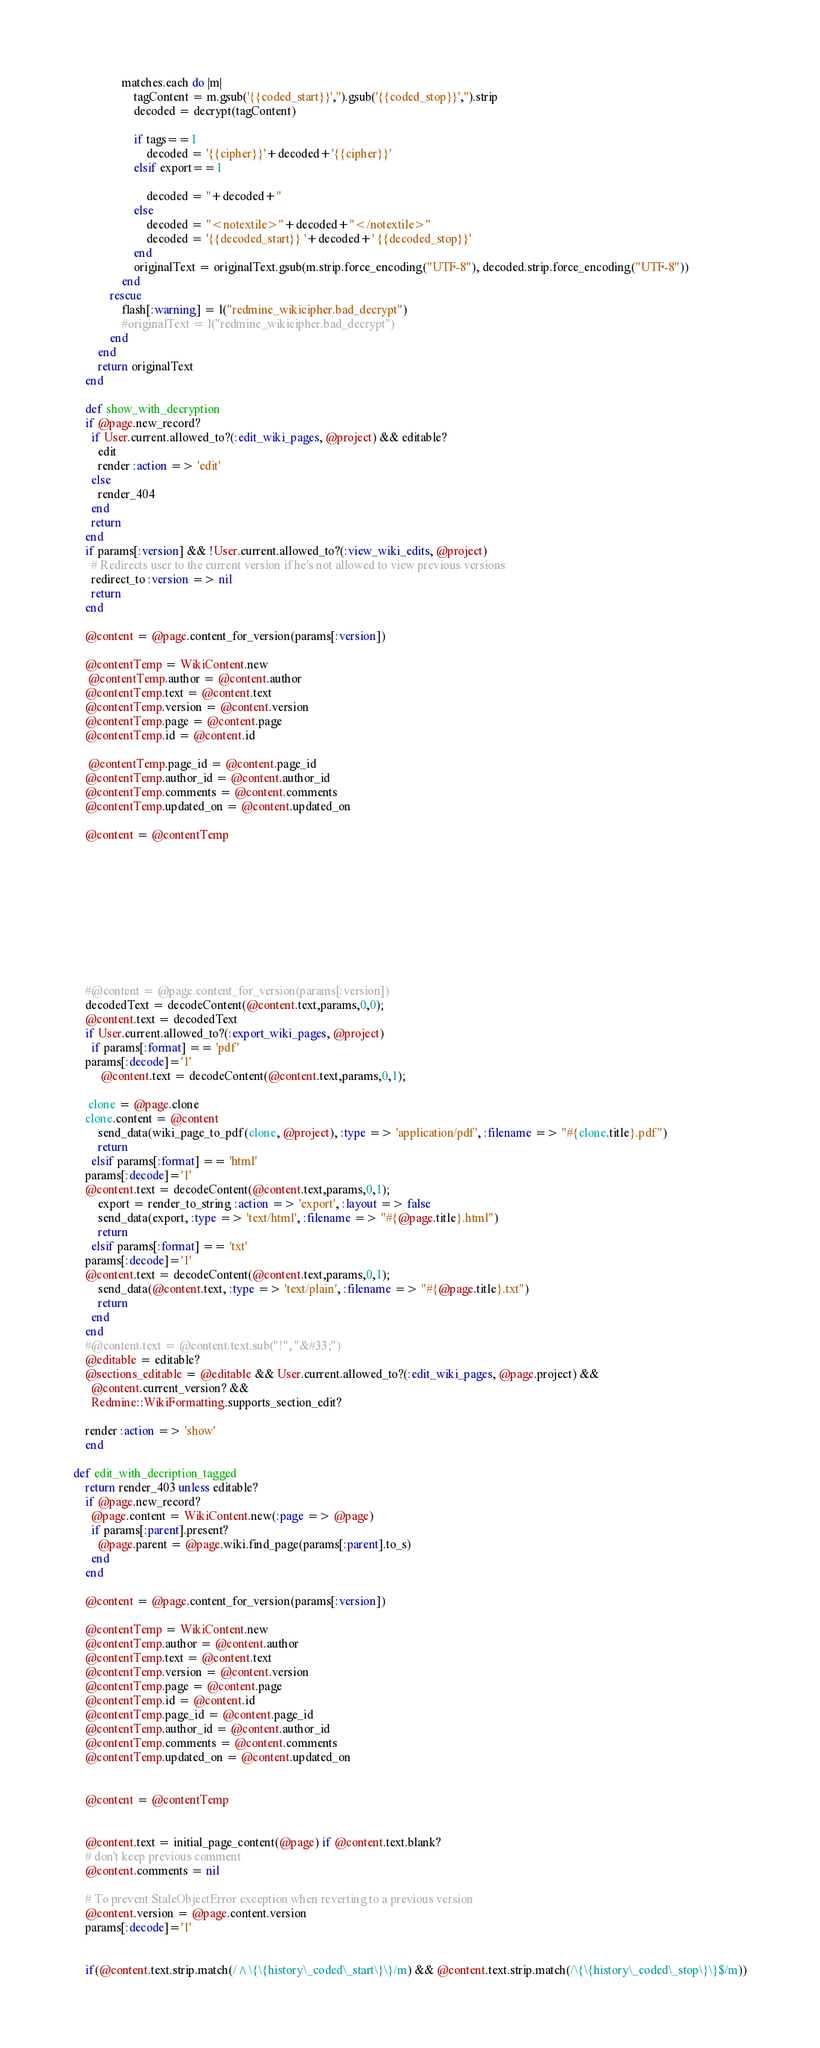<code> <loc_0><loc_0><loc_500><loc_500><_Ruby_>				matches.each do |m|
					tagContent = m.gsub('{{coded_start}}','').gsub('{{coded_stop}}','').strip
					decoded = decrypt(tagContent)
				
					if tags==1
						decoded = '{{cipher}}'+decoded+'{{cipher}}'
					elsif export==1

						decoded = ''+decoded+''
					else
						decoded = "<notextile>"+decoded+"</notextile>"
						decoded = '{{decoded_start}} '+decoded+' {{decoded_stop}}'
					end
					originalText = originalText.gsub(m.strip.force_encoding("UTF-8"), decoded.strip.force_encoding("UTF-8"))
				end	
			rescue
				flash[:warning] = l("redmine_wikicipher.bad_decrypt")
				#originalText = l("redmine_wikicipher.bad_decrypt")
			end		
		end
		return originalText
	end

    def show_with_decryption
	if @page.new_record?
      if User.current.allowed_to?(:edit_wiki_pages, @project) && editable?
        edit
        render :action => 'edit'
      else
        render_404
      end
      return
    end
    if params[:version] && !User.current.allowed_to?(:view_wiki_edits, @project)
      # Redirects user to the current version if he's not allowed to view previous versions
      redirect_to :version => nil
      return
    end

    @content = @page.content_for_version(params[:version])

    @contentTemp = WikiContent.new
     @contentTemp.author = @content.author
    @contentTemp.text = @content.text
    @contentTemp.version = @content.version
    @contentTemp.page = @content.page
    @contentTemp.id = @content.id

     @contentTemp.page_id = @content.page_id
    @contentTemp.author_id = @content.author_id
    @contentTemp.comments = @content.comments
    @contentTemp.updated_on = @content.updated_on

    @content = @contentTemp










    #@content = @page.content_for_version(params[:version])
    decodedText = decodeContent(@content.text,params,0,0);
    @content.text = decodedText
    if User.current.allowed_to?(:export_wiki_pages, @project)
      if params[:format] == 'pdf'
	params[:decode]='1'
         @content.text = decodeContent(@content.text,params,0,1);
	 
	 clone = @page.clone
	clone.content = @content
        send_data(wiki_page_to_pdf(clone, @project), :type => 'application/pdf', :filename => "#{clone.title}.pdf")
        return
      elsif params[:format] == 'html'
	params[:decode]='1'
	@content.text = decodeContent(@content.text,params,0,1);
        export = render_to_string :action => 'export', :layout => false
        send_data(export, :type => 'text/html', :filename => "#{@page.title}.html")
        return
      elsif params[:format] == 'txt'
	params[:decode]='1'
	@content.text = decodeContent(@content.text,params,0,1);
        send_data(@content.text, :type => 'text/plain', :filename => "#{@page.title}.txt")
        return
      end
    end
    #@content.text = @content.text.sub("!", "&#33;")
    @editable = editable?
    @sections_editable = @editable && User.current.allowed_to?(:edit_wiki_pages, @page.project) &&
      @content.current_version? &&
      Redmine::WikiFormatting.supports_section_edit?

    render :action => 'show'
    end
   
def edit_with_decription_tagged
	return render_403 unless editable?
    if @page.new_record?
      @page.content = WikiContent.new(:page => @page)
      if params[:parent].present?
        @page.parent = @page.wiki.find_page(params[:parent].to_s)
      end
    end
   
    @content = @page.content_for_version(params[:version])
   
    @contentTemp = WikiContent.new
    @contentTemp.author = @content.author
    @contentTemp.text = @content.text
    @contentTemp.version = @content.version
    @contentTemp.page = @content.page
    @contentTemp.id = @content.id
    @contentTemp.page_id = @content.page_id
    @contentTemp.author_id = @content.author_id
    @contentTemp.comments = @content.comments
    @contentTemp.updated_on = @content.updated_on


    @content = @contentTemp
    

    @content.text = initial_page_content(@page) if @content.text.blank?
    # don't keep previous comment
    @content.comments = nil

    # To prevent StaleObjectError exception when reverting to a previous version
    @content.version = @page.content.version
    params[:decode]='1'
 

    if(@content.text.strip.match(/^\{\{history\_coded\_start\}\}/m) && @content.text.strip.match(/\{\{history\_coded\_stop\}\}$/m))</code> 